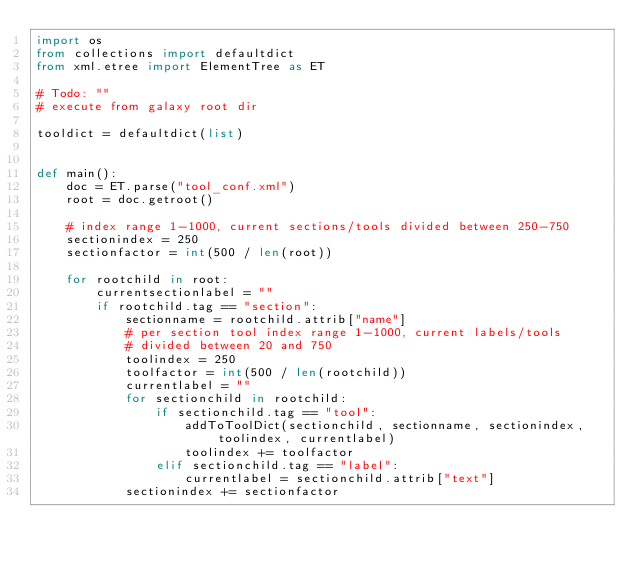Convert code to text. <code><loc_0><loc_0><loc_500><loc_500><_Python_>import os
from collections import defaultdict
from xml.etree import ElementTree as ET

# Todo: ""
# execute from galaxy root dir

tooldict = defaultdict(list)


def main():
    doc = ET.parse("tool_conf.xml")
    root = doc.getroot()

    # index range 1-1000, current sections/tools divided between 250-750
    sectionindex = 250
    sectionfactor = int(500 / len(root))

    for rootchild in root:
        currentsectionlabel = ""
        if rootchild.tag == "section":
            sectionname = rootchild.attrib["name"]
            # per section tool index range 1-1000, current labels/tools
            # divided between 20 and 750
            toolindex = 250
            toolfactor = int(500 / len(rootchild))
            currentlabel = ""
            for sectionchild in rootchild:
                if sectionchild.tag == "tool":
                    addToToolDict(sectionchild, sectionname, sectionindex, toolindex, currentlabel)
                    toolindex += toolfactor
                elif sectionchild.tag == "label":
                    currentlabel = sectionchild.attrib["text"]
            sectionindex += sectionfactor</code> 